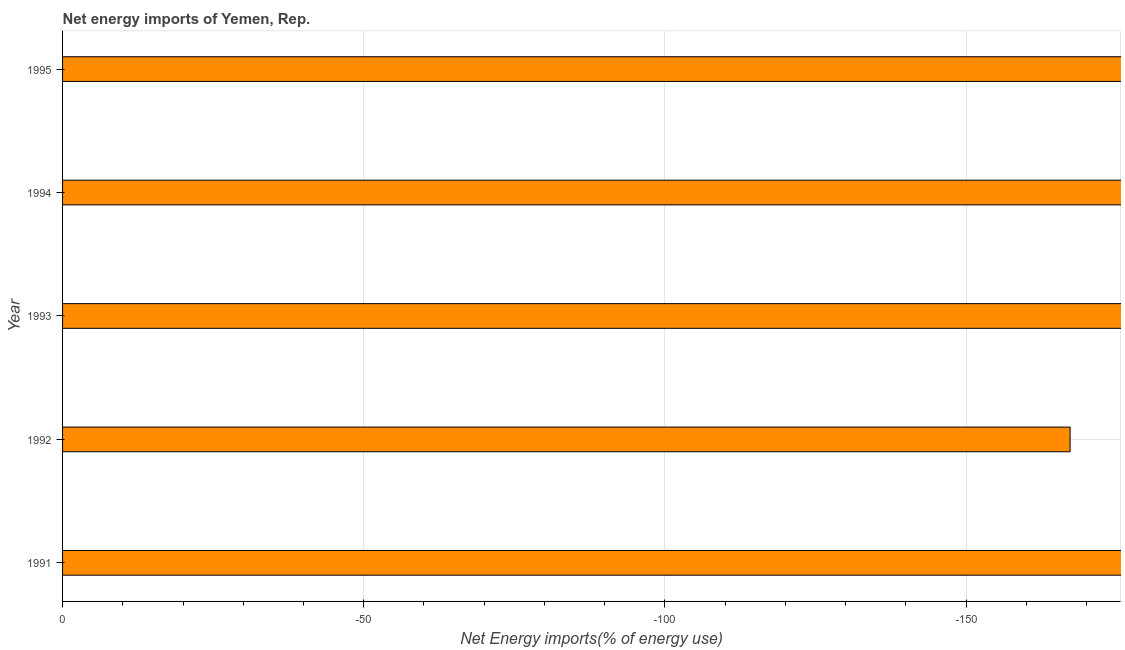Does the graph contain any zero values?
Your response must be concise. Yes. What is the title of the graph?
Your answer should be very brief. Net energy imports of Yemen, Rep. What is the label or title of the X-axis?
Offer a very short reply. Net Energy imports(% of energy use). Across all years, what is the minimum energy imports?
Your response must be concise. 0. What is the average energy imports per year?
Provide a short and direct response. 0. What is the median energy imports?
Give a very brief answer. 0. In how many years, is the energy imports greater than -40 %?
Offer a terse response. 0. How many bars are there?
Provide a short and direct response. 0. Are all the bars in the graph horizontal?
Your answer should be compact. Yes. How many years are there in the graph?
Your answer should be compact. 5. What is the difference between two consecutive major ticks on the X-axis?
Your answer should be compact. 50. What is the Net Energy imports(% of energy use) of 1993?
Your answer should be very brief. 0. What is the Net Energy imports(% of energy use) of 1994?
Make the answer very short. 0. What is the Net Energy imports(% of energy use) of 1995?
Offer a very short reply. 0. 